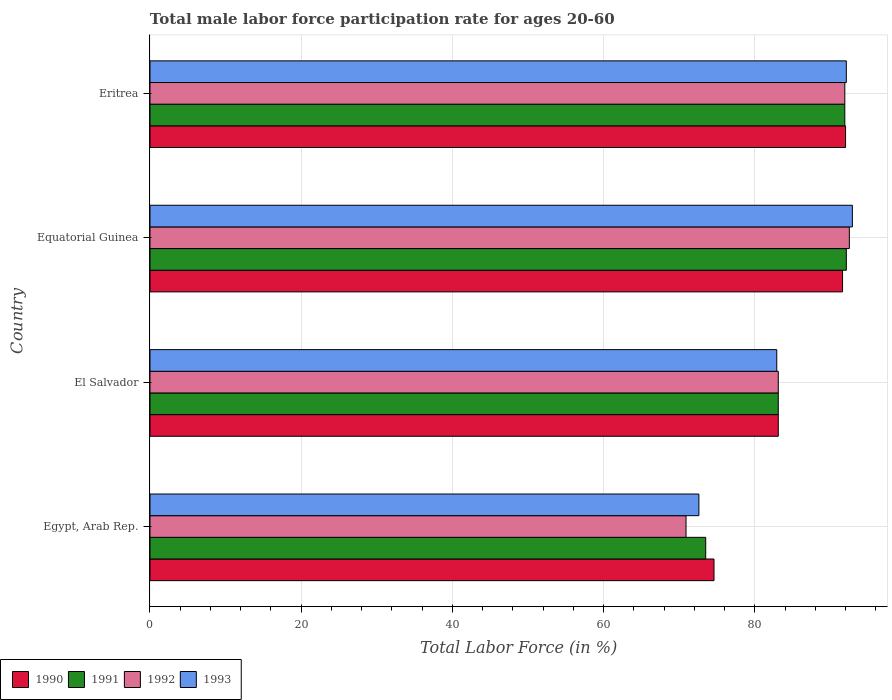How many different coloured bars are there?
Your answer should be very brief. 4. Are the number of bars per tick equal to the number of legend labels?
Keep it short and to the point. Yes. Are the number of bars on each tick of the Y-axis equal?
Ensure brevity in your answer.  Yes. How many bars are there on the 2nd tick from the top?
Offer a very short reply. 4. How many bars are there on the 3rd tick from the bottom?
Provide a short and direct response. 4. What is the label of the 3rd group of bars from the top?
Ensure brevity in your answer.  El Salvador. In how many cases, is the number of bars for a given country not equal to the number of legend labels?
Make the answer very short. 0. What is the male labor force participation rate in 1993 in Equatorial Guinea?
Offer a terse response. 92.9. Across all countries, what is the maximum male labor force participation rate in 1992?
Offer a terse response. 92.5. Across all countries, what is the minimum male labor force participation rate in 1991?
Your answer should be very brief. 73.5. In which country was the male labor force participation rate in 1993 maximum?
Your answer should be very brief. Equatorial Guinea. In which country was the male labor force participation rate in 1993 minimum?
Your response must be concise. Egypt, Arab Rep. What is the total male labor force participation rate in 1992 in the graph?
Offer a very short reply. 338.4. What is the difference between the male labor force participation rate in 1991 in Egypt, Arab Rep. and that in El Salvador?
Make the answer very short. -9.6. What is the difference between the male labor force participation rate in 1992 in El Salvador and the male labor force participation rate in 1993 in Equatorial Guinea?
Make the answer very short. -9.8. What is the average male labor force participation rate in 1991 per country?
Give a very brief answer. 85.15. What is the difference between the male labor force participation rate in 1990 and male labor force participation rate in 1992 in Eritrea?
Keep it short and to the point. 0.1. In how many countries, is the male labor force participation rate in 1992 greater than 92 %?
Keep it short and to the point. 1. What is the ratio of the male labor force participation rate in 1990 in Egypt, Arab Rep. to that in El Salvador?
Provide a succinct answer. 0.9. Is the male labor force participation rate in 1990 in Egypt, Arab Rep. less than that in El Salvador?
Keep it short and to the point. Yes. What is the difference between the highest and the second highest male labor force participation rate in 1993?
Keep it short and to the point. 0.8. What is the difference between the highest and the lowest male labor force participation rate in 1992?
Provide a succinct answer. 21.6. Is the sum of the male labor force participation rate in 1990 in Egypt, Arab Rep. and Equatorial Guinea greater than the maximum male labor force participation rate in 1993 across all countries?
Your answer should be very brief. Yes. What does the 1st bar from the top in Egypt, Arab Rep. represents?
Ensure brevity in your answer.  1993. How many bars are there?
Provide a succinct answer. 16. Are all the bars in the graph horizontal?
Make the answer very short. Yes. What is the difference between two consecutive major ticks on the X-axis?
Keep it short and to the point. 20. Are the values on the major ticks of X-axis written in scientific E-notation?
Ensure brevity in your answer.  No. What is the title of the graph?
Your answer should be compact. Total male labor force participation rate for ages 20-60. Does "1996" appear as one of the legend labels in the graph?
Keep it short and to the point. No. What is the Total Labor Force (in %) in 1990 in Egypt, Arab Rep.?
Ensure brevity in your answer.  74.6. What is the Total Labor Force (in %) in 1991 in Egypt, Arab Rep.?
Provide a succinct answer. 73.5. What is the Total Labor Force (in %) in 1992 in Egypt, Arab Rep.?
Provide a succinct answer. 70.9. What is the Total Labor Force (in %) in 1993 in Egypt, Arab Rep.?
Offer a very short reply. 72.6. What is the Total Labor Force (in %) in 1990 in El Salvador?
Offer a terse response. 83.1. What is the Total Labor Force (in %) of 1991 in El Salvador?
Ensure brevity in your answer.  83.1. What is the Total Labor Force (in %) in 1992 in El Salvador?
Your answer should be very brief. 83.1. What is the Total Labor Force (in %) of 1993 in El Salvador?
Provide a short and direct response. 82.9. What is the Total Labor Force (in %) of 1990 in Equatorial Guinea?
Provide a short and direct response. 91.6. What is the Total Labor Force (in %) of 1991 in Equatorial Guinea?
Keep it short and to the point. 92.1. What is the Total Labor Force (in %) of 1992 in Equatorial Guinea?
Ensure brevity in your answer.  92.5. What is the Total Labor Force (in %) of 1993 in Equatorial Guinea?
Offer a terse response. 92.9. What is the Total Labor Force (in %) of 1990 in Eritrea?
Offer a terse response. 92. What is the Total Labor Force (in %) in 1991 in Eritrea?
Your response must be concise. 91.9. What is the Total Labor Force (in %) in 1992 in Eritrea?
Give a very brief answer. 91.9. What is the Total Labor Force (in %) in 1993 in Eritrea?
Ensure brevity in your answer.  92.1. Across all countries, what is the maximum Total Labor Force (in %) of 1990?
Offer a terse response. 92. Across all countries, what is the maximum Total Labor Force (in %) in 1991?
Provide a short and direct response. 92.1. Across all countries, what is the maximum Total Labor Force (in %) in 1992?
Provide a short and direct response. 92.5. Across all countries, what is the maximum Total Labor Force (in %) of 1993?
Keep it short and to the point. 92.9. Across all countries, what is the minimum Total Labor Force (in %) in 1990?
Offer a terse response. 74.6. Across all countries, what is the minimum Total Labor Force (in %) in 1991?
Your answer should be very brief. 73.5. Across all countries, what is the minimum Total Labor Force (in %) in 1992?
Keep it short and to the point. 70.9. Across all countries, what is the minimum Total Labor Force (in %) of 1993?
Ensure brevity in your answer.  72.6. What is the total Total Labor Force (in %) of 1990 in the graph?
Your response must be concise. 341.3. What is the total Total Labor Force (in %) in 1991 in the graph?
Your response must be concise. 340.6. What is the total Total Labor Force (in %) of 1992 in the graph?
Your answer should be very brief. 338.4. What is the total Total Labor Force (in %) in 1993 in the graph?
Provide a succinct answer. 340.5. What is the difference between the Total Labor Force (in %) in 1990 in Egypt, Arab Rep. and that in El Salvador?
Your answer should be very brief. -8.5. What is the difference between the Total Labor Force (in %) of 1990 in Egypt, Arab Rep. and that in Equatorial Guinea?
Make the answer very short. -17. What is the difference between the Total Labor Force (in %) in 1991 in Egypt, Arab Rep. and that in Equatorial Guinea?
Keep it short and to the point. -18.6. What is the difference between the Total Labor Force (in %) in 1992 in Egypt, Arab Rep. and that in Equatorial Guinea?
Give a very brief answer. -21.6. What is the difference between the Total Labor Force (in %) of 1993 in Egypt, Arab Rep. and that in Equatorial Guinea?
Your answer should be compact. -20.3. What is the difference between the Total Labor Force (in %) of 1990 in Egypt, Arab Rep. and that in Eritrea?
Keep it short and to the point. -17.4. What is the difference between the Total Labor Force (in %) of 1991 in Egypt, Arab Rep. and that in Eritrea?
Offer a terse response. -18.4. What is the difference between the Total Labor Force (in %) of 1992 in Egypt, Arab Rep. and that in Eritrea?
Keep it short and to the point. -21. What is the difference between the Total Labor Force (in %) in 1993 in Egypt, Arab Rep. and that in Eritrea?
Your answer should be compact. -19.5. What is the difference between the Total Labor Force (in %) in 1990 in El Salvador and that in Equatorial Guinea?
Make the answer very short. -8.5. What is the difference between the Total Labor Force (in %) in 1991 in El Salvador and that in Equatorial Guinea?
Make the answer very short. -9. What is the difference between the Total Labor Force (in %) of 1992 in El Salvador and that in Equatorial Guinea?
Your response must be concise. -9.4. What is the difference between the Total Labor Force (in %) of 1993 in El Salvador and that in Eritrea?
Ensure brevity in your answer.  -9.2. What is the difference between the Total Labor Force (in %) of 1990 in Equatorial Guinea and that in Eritrea?
Your answer should be compact. -0.4. What is the difference between the Total Labor Force (in %) of 1992 in Equatorial Guinea and that in Eritrea?
Provide a short and direct response. 0.6. What is the difference between the Total Labor Force (in %) of 1993 in Equatorial Guinea and that in Eritrea?
Ensure brevity in your answer.  0.8. What is the difference between the Total Labor Force (in %) in 1990 in Egypt, Arab Rep. and the Total Labor Force (in %) in 1993 in El Salvador?
Your answer should be very brief. -8.3. What is the difference between the Total Labor Force (in %) of 1991 in Egypt, Arab Rep. and the Total Labor Force (in %) of 1992 in El Salvador?
Offer a terse response. -9.6. What is the difference between the Total Labor Force (in %) of 1992 in Egypt, Arab Rep. and the Total Labor Force (in %) of 1993 in El Salvador?
Your answer should be compact. -12. What is the difference between the Total Labor Force (in %) in 1990 in Egypt, Arab Rep. and the Total Labor Force (in %) in 1991 in Equatorial Guinea?
Provide a short and direct response. -17.5. What is the difference between the Total Labor Force (in %) of 1990 in Egypt, Arab Rep. and the Total Labor Force (in %) of 1992 in Equatorial Guinea?
Ensure brevity in your answer.  -17.9. What is the difference between the Total Labor Force (in %) in 1990 in Egypt, Arab Rep. and the Total Labor Force (in %) in 1993 in Equatorial Guinea?
Offer a very short reply. -18.3. What is the difference between the Total Labor Force (in %) in 1991 in Egypt, Arab Rep. and the Total Labor Force (in %) in 1993 in Equatorial Guinea?
Make the answer very short. -19.4. What is the difference between the Total Labor Force (in %) in 1990 in Egypt, Arab Rep. and the Total Labor Force (in %) in 1991 in Eritrea?
Your answer should be very brief. -17.3. What is the difference between the Total Labor Force (in %) of 1990 in Egypt, Arab Rep. and the Total Labor Force (in %) of 1992 in Eritrea?
Your answer should be compact. -17.3. What is the difference between the Total Labor Force (in %) of 1990 in Egypt, Arab Rep. and the Total Labor Force (in %) of 1993 in Eritrea?
Ensure brevity in your answer.  -17.5. What is the difference between the Total Labor Force (in %) in 1991 in Egypt, Arab Rep. and the Total Labor Force (in %) in 1992 in Eritrea?
Provide a succinct answer. -18.4. What is the difference between the Total Labor Force (in %) in 1991 in Egypt, Arab Rep. and the Total Labor Force (in %) in 1993 in Eritrea?
Make the answer very short. -18.6. What is the difference between the Total Labor Force (in %) of 1992 in Egypt, Arab Rep. and the Total Labor Force (in %) of 1993 in Eritrea?
Ensure brevity in your answer.  -21.2. What is the difference between the Total Labor Force (in %) of 1990 in El Salvador and the Total Labor Force (in %) of 1993 in Equatorial Guinea?
Give a very brief answer. -9.8. What is the difference between the Total Labor Force (in %) in 1990 in El Salvador and the Total Labor Force (in %) in 1991 in Eritrea?
Ensure brevity in your answer.  -8.8. What is the difference between the Total Labor Force (in %) of 1990 in El Salvador and the Total Labor Force (in %) of 1993 in Eritrea?
Your answer should be compact. -9. What is the difference between the Total Labor Force (in %) in 1991 in El Salvador and the Total Labor Force (in %) in 1992 in Eritrea?
Your answer should be compact. -8.8. What is the difference between the Total Labor Force (in %) in 1992 in El Salvador and the Total Labor Force (in %) in 1993 in Eritrea?
Offer a terse response. -9. What is the difference between the Total Labor Force (in %) in 1990 in Equatorial Guinea and the Total Labor Force (in %) in 1991 in Eritrea?
Give a very brief answer. -0.3. What is the difference between the Total Labor Force (in %) of 1990 in Equatorial Guinea and the Total Labor Force (in %) of 1992 in Eritrea?
Make the answer very short. -0.3. What is the difference between the Total Labor Force (in %) in 1991 in Equatorial Guinea and the Total Labor Force (in %) in 1993 in Eritrea?
Ensure brevity in your answer.  0. What is the difference between the Total Labor Force (in %) in 1992 in Equatorial Guinea and the Total Labor Force (in %) in 1993 in Eritrea?
Give a very brief answer. 0.4. What is the average Total Labor Force (in %) in 1990 per country?
Make the answer very short. 85.33. What is the average Total Labor Force (in %) in 1991 per country?
Provide a succinct answer. 85.15. What is the average Total Labor Force (in %) of 1992 per country?
Keep it short and to the point. 84.6. What is the average Total Labor Force (in %) in 1993 per country?
Make the answer very short. 85.12. What is the difference between the Total Labor Force (in %) of 1990 and Total Labor Force (in %) of 1993 in Egypt, Arab Rep.?
Offer a terse response. 2. What is the difference between the Total Labor Force (in %) of 1991 and Total Labor Force (in %) of 1992 in Egypt, Arab Rep.?
Keep it short and to the point. 2.6. What is the difference between the Total Labor Force (in %) of 1992 and Total Labor Force (in %) of 1993 in Egypt, Arab Rep.?
Provide a short and direct response. -1.7. What is the difference between the Total Labor Force (in %) in 1990 and Total Labor Force (in %) in 1993 in El Salvador?
Keep it short and to the point. 0.2. What is the difference between the Total Labor Force (in %) of 1992 and Total Labor Force (in %) of 1993 in El Salvador?
Ensure brevity in your answer.  0.2. What is the difference between the Total Labor Force (in %) in 1991 and Total Labor Force (in %) in 1992 in Equatorial Guinea?
Offer a very short reply. -0.4. What is the difference between the Total Labor Force (in %) in 1992 and Total Labor Force (in %) in 1993 in Equatorial Guinea?
Keep it short and to the point. -0.4. What is the difference between the Total Labor Force (in %) of 1990 and Total Labor Force (in %) of 1991 in Eritrea?
Offer a very short reply. 0.1. What is the difference between the Total Labor Force (in %) of 1990 and Total Labor Force (in %) of 1992 in Eritrea?
Offer a terse response. 0.1. What is the difference between the Total Labor Force (in %) in 1991 and Total Labor Force (in %) in 1992 in Eritrea?
Offer a very short reply. 0. What is the difference between the Total Labor Force (in %) of 1991 and Total Labor Force (in %) of 1993 in Eritrea?
Provide a succinct answer. -0.2. What is the difference between the Total Labor Force (in %) of 1992 and Total Labor Force (in %) of 1993 in Eritrea?
Ensure brevity in your answer.  -0.2. What is the ratio of the Total Labor Force (in %) of 1990 in Egypt, Arab Rep. to that in El Salvador?
Your answer should be very brief. 0.9. What is the ratio of the Total Labor Force (in %) in 1991 in Egypt, Arab Rep. to that in El Salvador?
Your response must be concise. 0.88. What is the ratio of the Total Labor Force (in %) of 1992 in Egypt, Arab Rep. to that in El Salvador?
Your answer should be very brief. 0.85. What is the ratio of the Total Labor Force (in %) in 1993 in Egypt, Arab Rep. to that in El Salvador?
Your answer should be compact. 0.88. What is the ratio of the Total Labor Force (in %) of 1990 in Egypt, Arab Rep. to that in Equatorial Guinea?
Offer a terse response. 0.81. What is the ratio of the Total Labor Force (in %) of 1991 in Egypt, Arab Rep. to that in Equatorial Guinea?
Offer a very short reply. 0.8. What is the ratio of the Total Labor Force (in %) in 1992 in Egypt, Arab Rep. to that in Equatorial Guinea?
Your answer should be very brief. 0.77. What is the ratio of the Total Labor Force (in %) in 1993 in Egypt, Arab Rep. to that in Equatorial Guinea?
Provide a succinct answer. 0.78. What is the ratio of the Total Labor Force (in %) in 1990 in Egypt, Arab Rep. to that in Eritrea?
Ensure brevity in your answer.  0.81. What is the ratio of the Total Labor Force (in %) in 1991 in Egypt, Arab Rep. to that in Eritrea?
Your answer should be very brief. 0.8. What is the ratio of the Total Labor Force (in %) in 1992 in Egypt, Arab Rep. to that in Eritrea?
Keep it short and to the point. 0.77. What is the ratio of the Total Labor Force (in %) in 1993 in Egypt, Arab Rep. to that in Eritrea?
Provide a short and direct response. 0.79. What is the ratio of the Total Labor Force (in %) of 1990 in El Salvador to that in Equatorial Guinea?
Give a very brief answer. 0.91. What is the ratio of the Total Labor Force (in %) of 1991 in El Salvador to that in Equatorial Guinea?
Provide a succinct answer. 0.9. What is the ratio of the Total Labor Force (in %) of 1992 in El Salvador to that in Equatorial Guinea?
Provide a succinct answer. 0.9. What is the ratio of the Total Labor Force (in %) in 1993 in El Salvador to that in Equatorial Guinea?
Your answer should be compact. 0.89. What is the ratio of the Total Labor Force (in %) in 1990 in El Salvador to that in Eritrea?
Give a very brief answer. 0.9. What is the ratio of the Total Labor Force (in %) in 1991 in El Salvador to that in Eritrea?
Offer a terse response. 0.9. What is the ratio of the Total Labor Force (in %) of 1992 in El Salvador to that in Eritrea?
Keep it short and to the point. 0.9. What is the ratio of the Total Labor Force (in %) of 1993 in El Salvador to that in Eritrea?
Provide a succinct answer. 0.9. What is the ratio of the Total Labor Force (in %) in 1992 in Equatorial Guinea to that in Eritrea?
Your response must be concise. 1.01. What is the ratio of the Total Labor Force (in %) in 1993 in Equatorial Guinea to that in Eritrea?
Your response must be concise. 1.01. What is the difference between the highest and the second highest Total Labor Force (in %) of 1992?
Your response must be concise. 0.6. What is the difference between the highest and the lowest Total Labor Force (in %) of 1992?
Keep it short and to the point. 21.6. What is the difference between the highest and the lowest Total Labor Force (in %) of 1993?
Your answer should be compact. 20.3. 